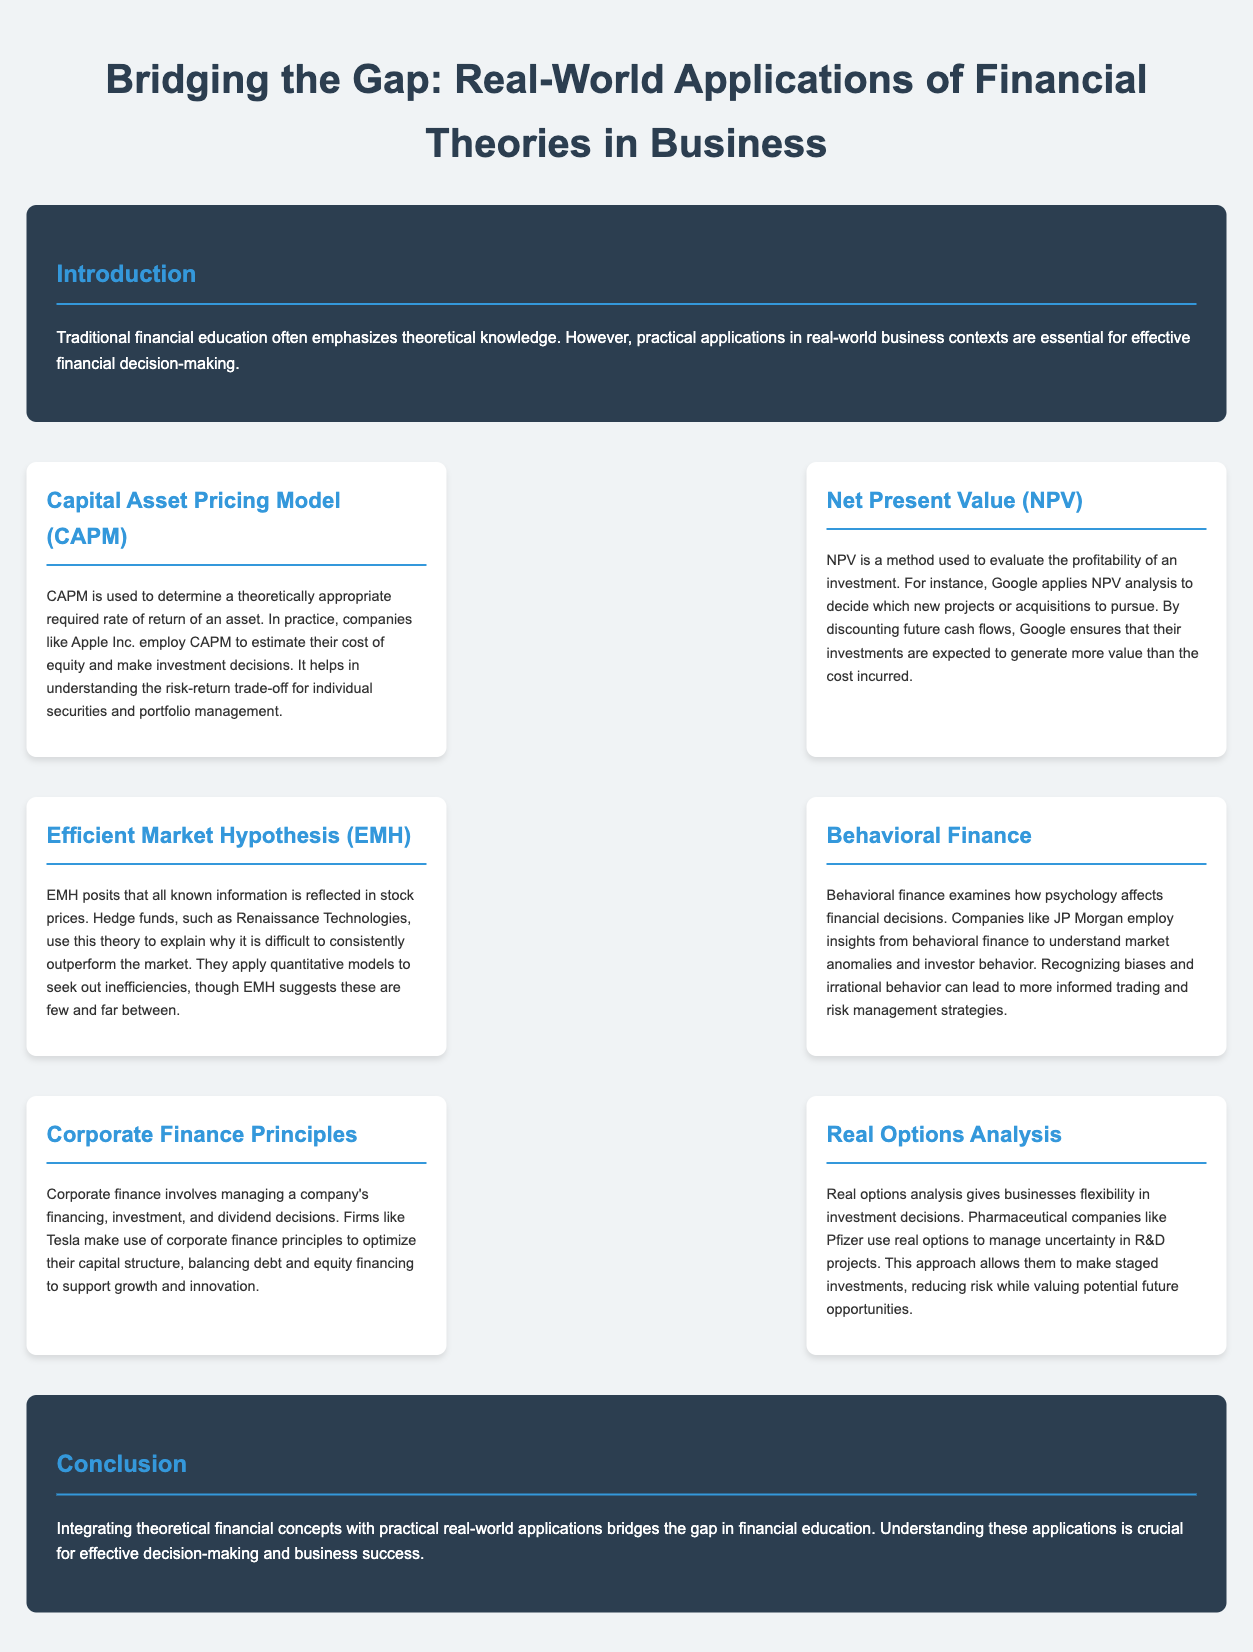What is the main focus of the infographic? The infographic focuses on bridging the gap between theoretical financial education and practical applications in business.
Answer: Bridging the gap between theoretical financial education and practical applications in business What company uses CAPM for investment decisions? The document mentions that Apple Inc. employs CAPM to estimate their cost of equity and make investment decisions.
Answer: Apple Inc Which financial method does Google apply to evaluate new projects? The document states that Google uses NPV analysis to decide which new projects or acquisitions to pursue.
Answer: NPV analysis What does EMH stand for? The acronym EMH is defined in the document as Efficient Market Hypothesis.
Answer: Efficient Market Hypothesis Which company is mentioned in relation to behavioral finance? JP Morgan is identified in the document as a company that employs insights from behavioral finance.
Answer: JP Morgan What is the purpose of Real Options Analysis according to the infographic? Real Options Analysis gives businesses flexibility in investment decisions, allowing them to manage uncertainty.
Answer: Flexibility in investment decisions How does Tesla utilize corporate finance principles? The infographic states that Tesla uses corporate finance principles to optimize their capital structure.
Answer: Optimize their capital structure What is the significance of integrating theoretical concepts with practical applications? The conclusion highlights the importance of this integration for effective decision-making and business success.
Answer: Effective decision-making and business success 